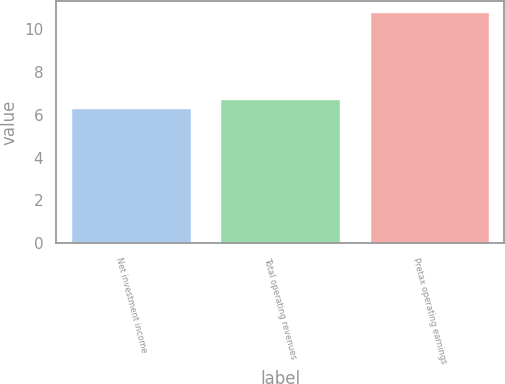Convert chart to OTSL. <chart><loc_0><loc_0><loc_500><loc_500><bar_chart><fcel>Net investment income<fcel>Total operating revenues<fcel>Pretax operating earnings<nl><fcel>6.3<fcel>6.75<fcel>10.8<nl></chart> 